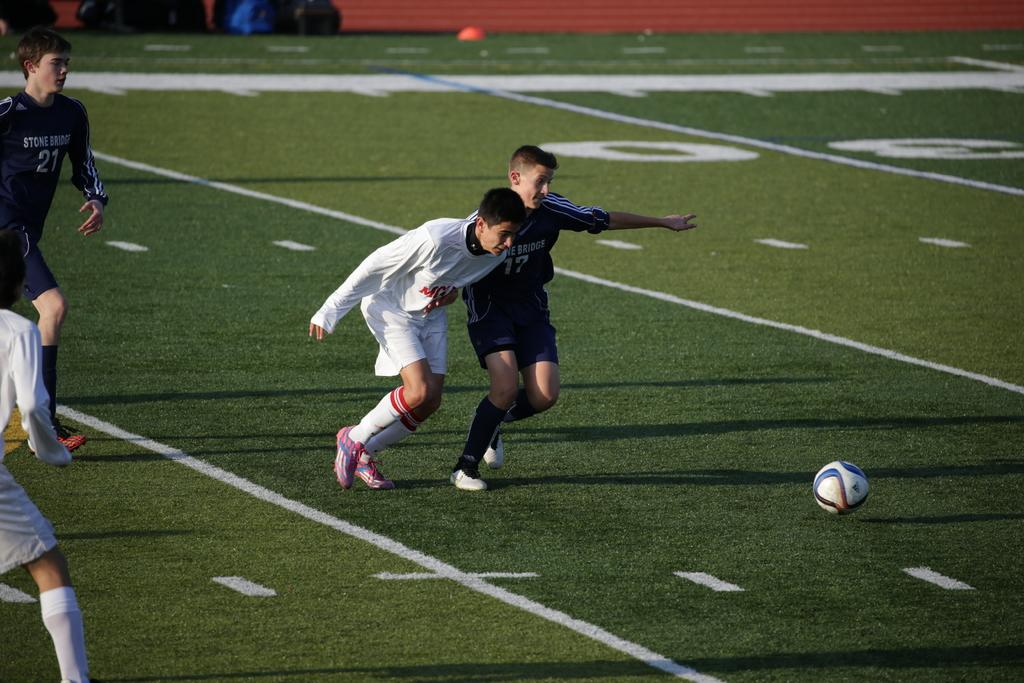<image>
Summarize the visual content of the image. Two soccer players are running towards the ball with the number 30 visible on the field. 